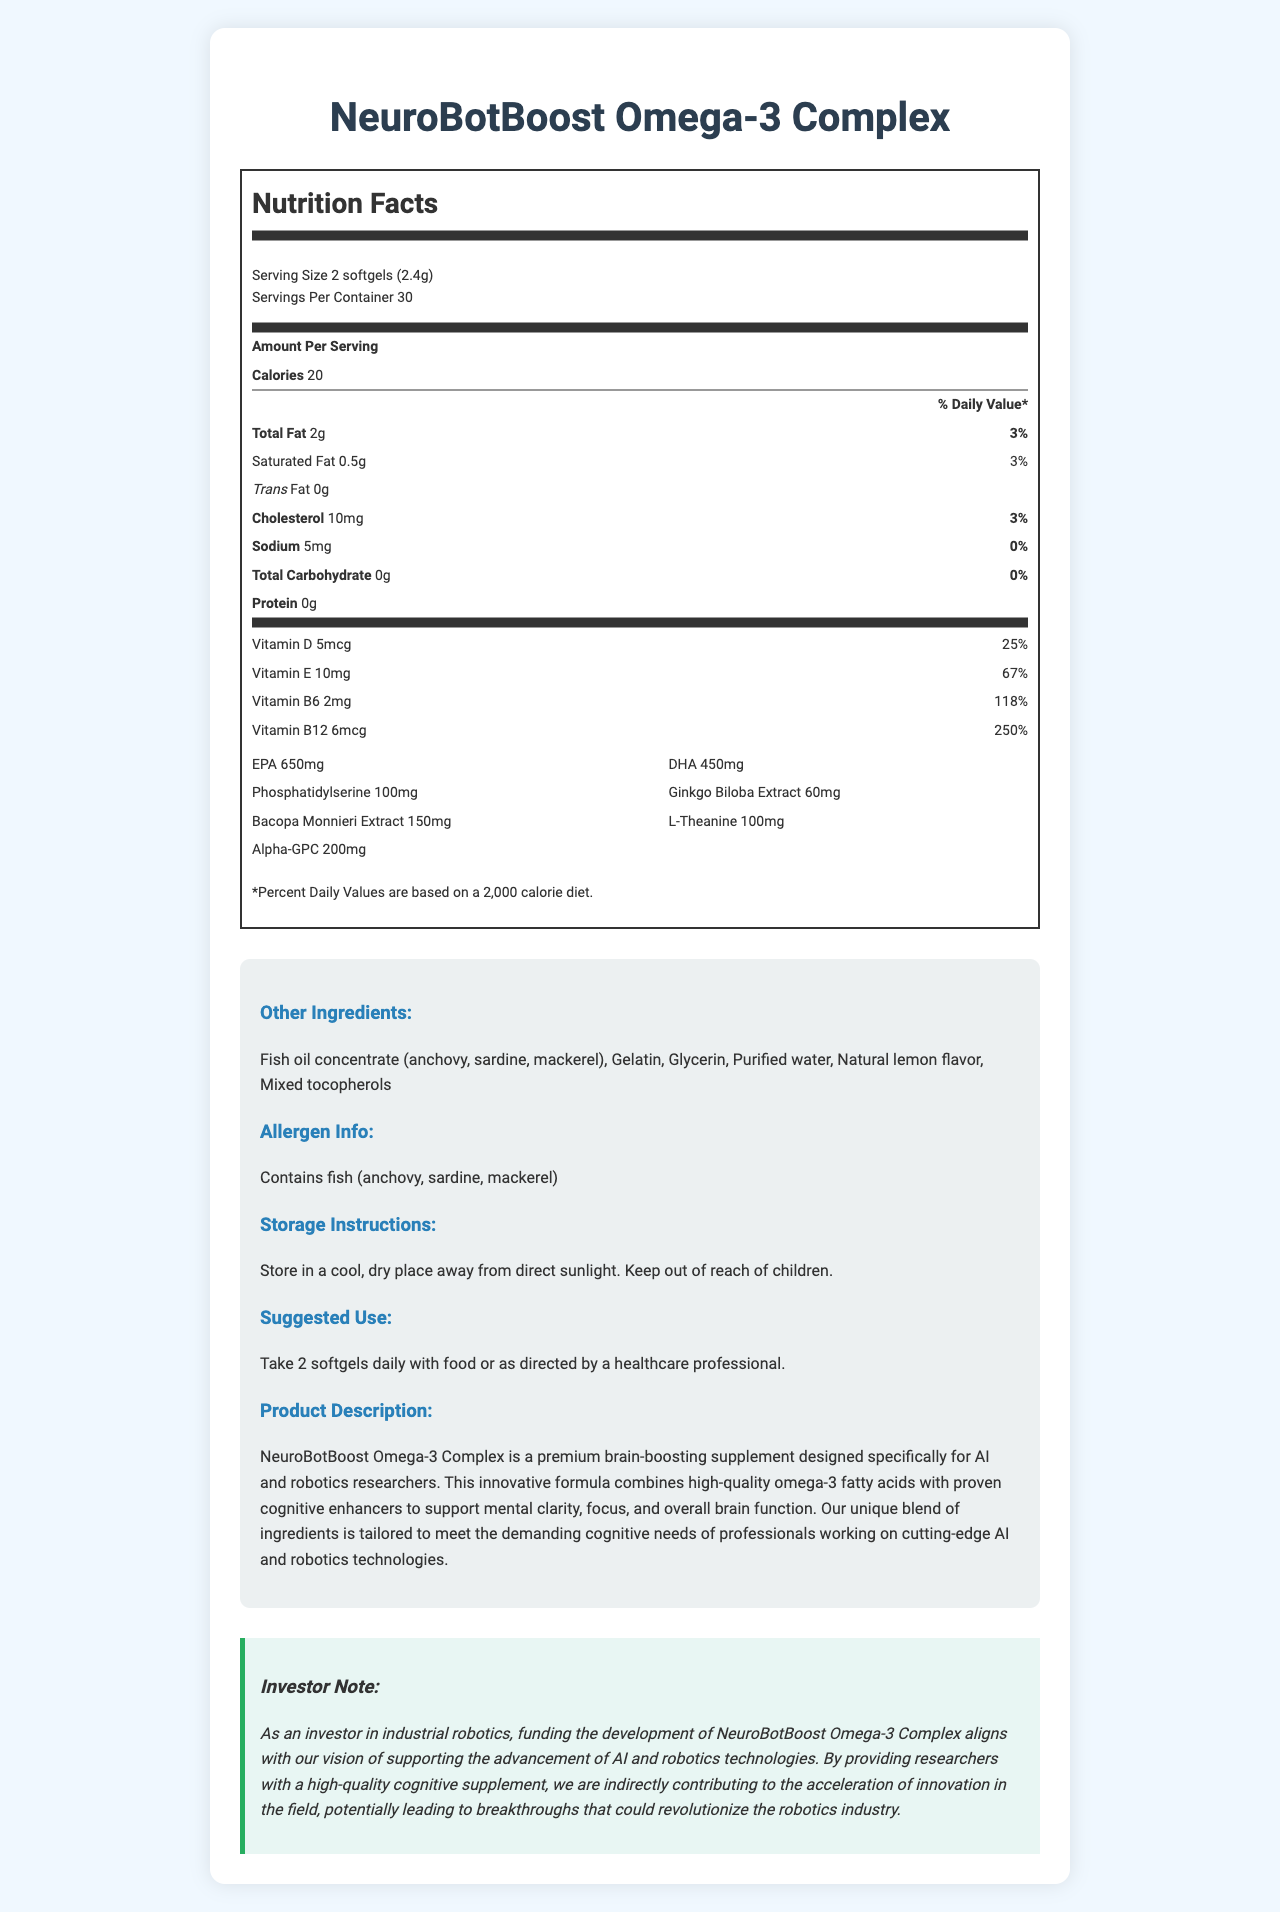What is the serving size for NeuroBotBoost Omega-3 Complex? The serving size is listed as "2 softgels (2.4g)" in the nutrition facts section.
Answer: 2 softgels (2.4g) How many servings are there per container? The container has 30 servings as mentioned in the nutrition facts section.
Answer: 30 What is the total amount of Omega-3 fatty acids (EPA and DHA) per serving? The document lists 650mg of EPA and 450mg of DHA, totaling 1100mg of Omega-3 fatty acids per serving.
Answer: 1100mg What percentage of the daily value for Vitamin B12 does each serving provide? The document states that each serving provides 250% of the daily value for Vitamin B12.
Answer: 250% Which ingredient in NeuroBotBoost Omega-3 Complex is specifically noted as an allergen? The allergen information section mentions that the product contains fish (anchovy, sardine, mackerel).
Answer: Fish (anchovy, sardine, mackerel) Which vitamins are included in NeuroBotBoost Omega-3 Complex? A. Vitamin A, Vitamin C, Vitamin E, and Vitamin K B. Vitamin D, Vitamin E, Vitamin B6, and Vitamin B12 C. Vitamin D, Vitamin C, Vitamin B1, and Vitamin B2 D. Vitamin E, Vitamin C, Vitamin K, and Vitamin B12 The document lists Vitamin D, E, B6, and B12 in the nutrition facts.
Answer: B What is the correct daily value percentage for saturated fat in this supplement? A. 3% B. 5% C. 10% D. 15% The document lists the daily value percentage for saturated fat as 3%.
Answer: A Does NeuroBotBoost Omega-3 Complex contain any trans fats? The nutrition facts section states that the supplement contains 0g of trans fat.
Answer: No Summarize the main idea of the document. The document explains the purpose, ingredients, and benefits of NeuroBotBoost Omega-3 Complex, highlighting its intention to support the cognitive needs of AI and robotics researchers and its relevance to investors in the field.
Answer: NeuroBotBoost Omega-3 Complex is a brain-boosting supplement specifically designed for AI and robotics researchers. It combines high-quality omega-3 fatty acids with cognitive enhancers such as Phosphatidylserine, Ginkgo Biloba Extract, and Bacopa Monnieri Extract. The product offers various vitamins and is intended to support mental clarity, focus, and overall brain function. It also includes a note to investors emphasizing the alignment of this product with the vision of supporting advancements in AI and robotics technologies. What is the exact amount of sodium per serving? The nutrition facts section states that there is 5mg of sodium per serving.
Answer: 5mg Is there any information on whether the softgels are vegan? The document does not provide any information on whether the softgels are vegan.
Answer: I don't know What are the storage instructions for NeuroBotBoost Omega-3 Complex? The storage instructions are explicitly mentioned in the "Storage Instructions" section of the document.
Answer: Store in a cool, dry place away from direct sunlight. Keep out of reach of children. What other ingredients are included in the NeuroBotBoost Omega-3 Complex, apart from the main active ingredients? The section titled "Other Ingredients" lists these additional components.
Answer: Fish oil concentrate (anchovy, sardine, mackerel), Gelatin, Glycerin, Purified water, Natural lemon flavor, Mixed tocopherols Which cognitive enhancer in NeuroBotBoost Omega-3 Complex is present in the largest amount per serving? The document shows that Alpha-GPC is present in the amount of 200mg, which is higher than the other cognitive enhancers listed.
Answer: Alpha-GPC What is the suggested use for NeuroBotBoost Omega-3 Complex? The "Suggested Use" section provides this information.
Answer: Take 2 softgels daily with food or as directed by a healthcare professional. 